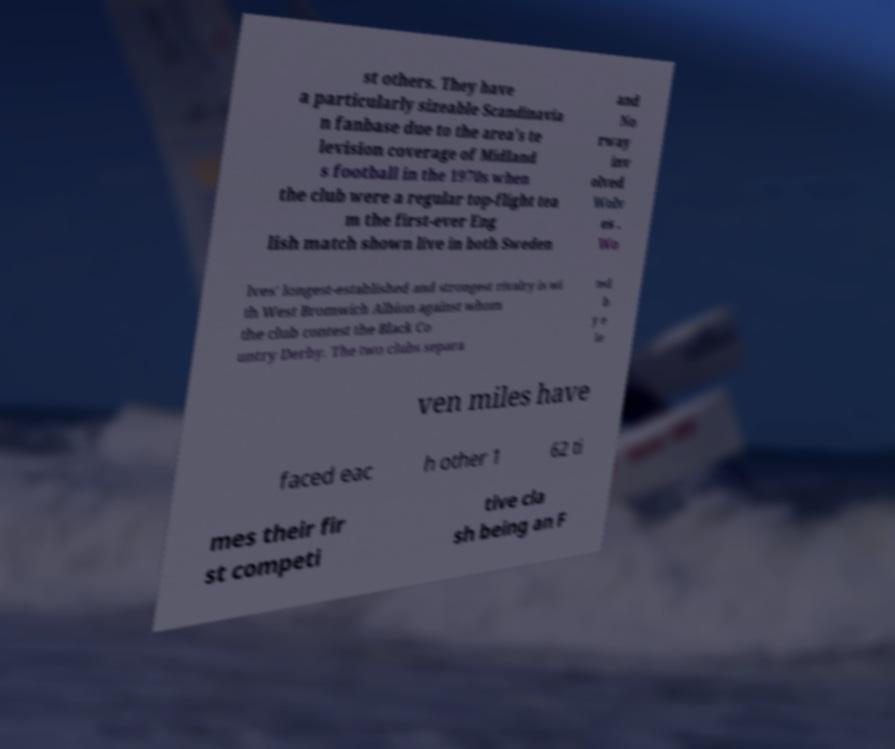Can you read and provide the text displayed in the image?This photo seems to have some interesting text. Can you extract and type it out for me? st others. They have a particularly sizeable Scandinavia n fanbase due to the area's te levision coverage of Midland s football in the 1970s when the club were a regular top-flight tea m the first-ever Eng lish match shown live in both Sweden and No rway inv olved Wolv es . Wo lves' longest-established and strongest rivalry is wi th West Bromwich Albion against whom the club contest the Black Co untry Derby. The two clubs separa ted b y e le ven miles have faced eac h other 1 62 ti mes their fir st competi tive cla sh being an F 